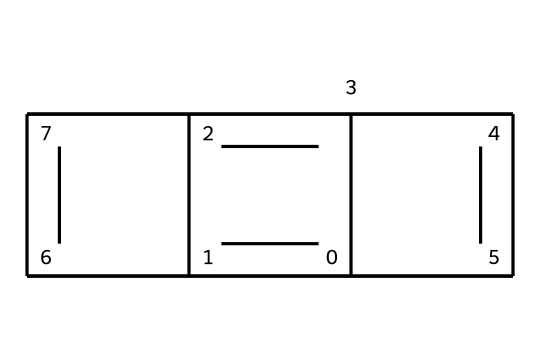What is the molecular formula of this chemical? To determine the molecular formula, we need to count the number of carbon atoms present in the structure represented by the SMILES. The structure indicates 10 carbon atoms. Therefore, the molecular formula is C10.
Answer: C10 How many rings are present in this chemical structure? The structure can be analyzed to identify the number of distinct cycles or rings formed. The connections suggest there are 5 interconnected rings in this chemical.
Answer: 5 What type of bonds are primarily found in this chemical? By examining the SMILES representation, we notice it primarily consists of carbon-carbon bonds. Since the structure looks like it may involve alternating single and double bonds, it indicates the presence of aromatic character, but mainly carbon-carbon.
Answer: carbon-carbon Which property makes this chemical suitable as a lubricant? The layered structure of graphite allows for easy sliding between layers, which reduces friction and wear between surfaces, making it suitable for use as a lubricant.
Answer: layered structure What are the potential effects of the presence of this chemical in electronic musical instruments? The presence of graphite powder provides conductive properties, benefiting electrical connections within the instruments. Its low friction qualities also help in reducing wear and tear of components.
Answer: conductive properties Does this chemical have hydrophobic characteristics? The nature of graphite suggests that it has hydrophobic properties, as the carbon structures do not engage easily with water, which helps in reducing moisture-related issues in electronic components.
Answer: hydrophobic 